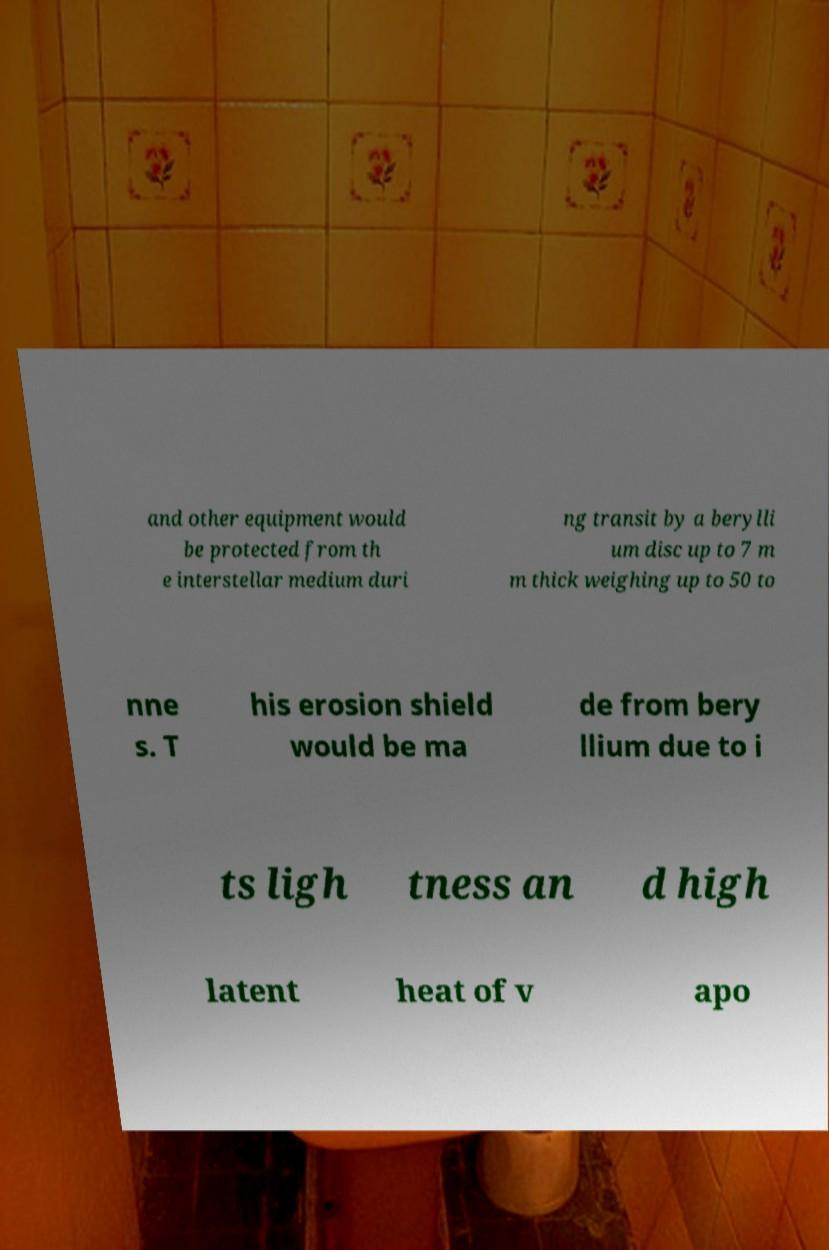I need the written content from this picture converted into text. Can you do that? and other equipment would be protected from th e interstellar medium duri ng transit by a berylli um disc up to 7 m m thick weighing up to 50 to nne s. T his erosion shield would be ma de from bery llium due to i ts ligh tness an d high latent heat of v apo 